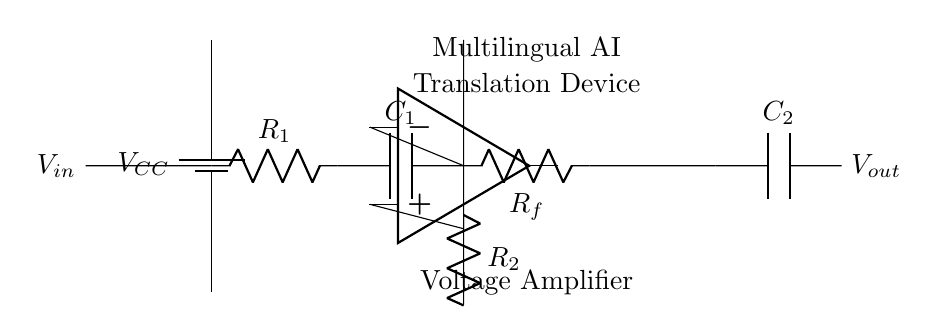What is the input voltage represented in the circuit? The input voltage is denoted as \(V_{in}\), which is indicated to the left of the circuit with the corresponding label.
Answer: \(V_{in}\) What is the value of resistor \(R_1\)? The value is not explicitly indicated in the circuit diagram; further specification or reference to a component list would be necessary to determine the value of \(R_1\).
Answer: Not indicated How many capacitors are present in the circuit? There are two capacitors shown in the diagram, labeled \(C_1\) and \(C_2\), which are located in the input and output stages respectively.
Answer: 2 What is the role of the feedback resistor \(R_f\)? The feedback resistor \(R_f\) connects the output to the inverting input of the amplifier, which is essential for controlling the gain of the amplifier by setting the feedback ratio.
Answer: Gain control What is the output voltage labeled in the circuit? The output voltage is indicated as \(V_{out}\), which is found on the far right of the circuit and shows the output of the amplification process.
Answer: \(V_{out}\) What type of amplifier is represented in the circuit? The circuit represents a voltage amplifier, as identified by the presence of an operational amplifier and the configuration of feedback components used to amplify voltage signals.
Answer: Voltage amplifier How does the capacitor \(C_1\) affect the circuit's operation? Capacitor \(C_1\) acts to couple AC signals into the amplifier while blocking any DC component from affecting the amplifier's input, allowing only the AC parts of a signal to be amplified.
Answer: AC coupling 